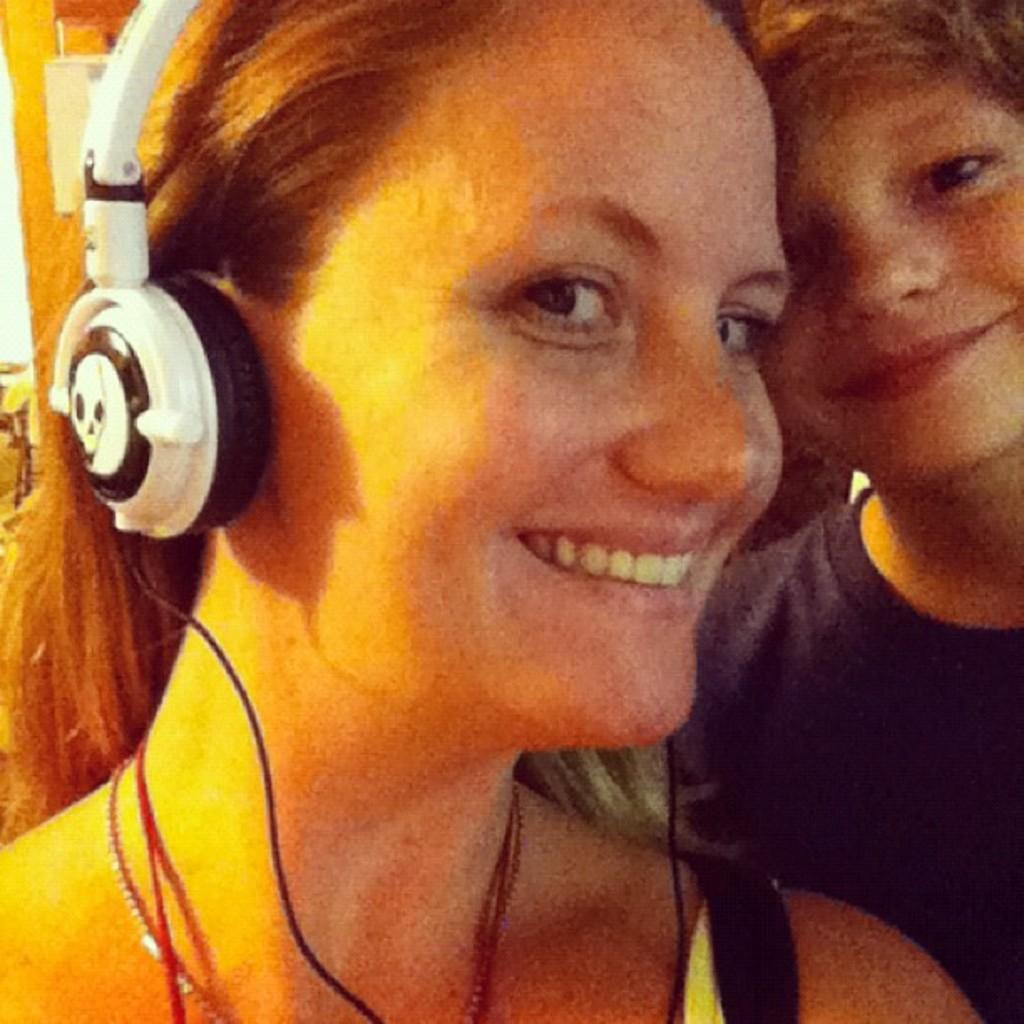Who is present in the image? There is a woman and a boy in the image. What is the woman wearing on her head? The woman is wearing headsets. What colors are the headsets? The headsets are white and black in color. What is the boy wearing? The boy is wearing a black colored t-shirt. What can be seen in the background of the image? There are other objects visible in the background of the image. What type of linen is draped over the lamp in the image? There is no lamp or linen present in the image. Can you describe the snake that is slithering across the floor in the image? There is no snake present in the image. 